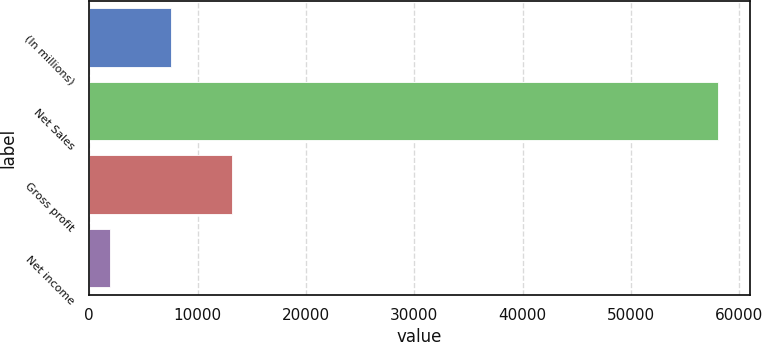Convert chart to OTSL. <chart><loc_0><loc_0><loc_500><loc_500><bar_chart><fcel>(In millions)<fcel>Net Sales<fcel>Gross profit<fcel>Net income<nl><fcel>7552.8<fcel>58068<fcel>13165.6<fcel>1940<nl></chart> 